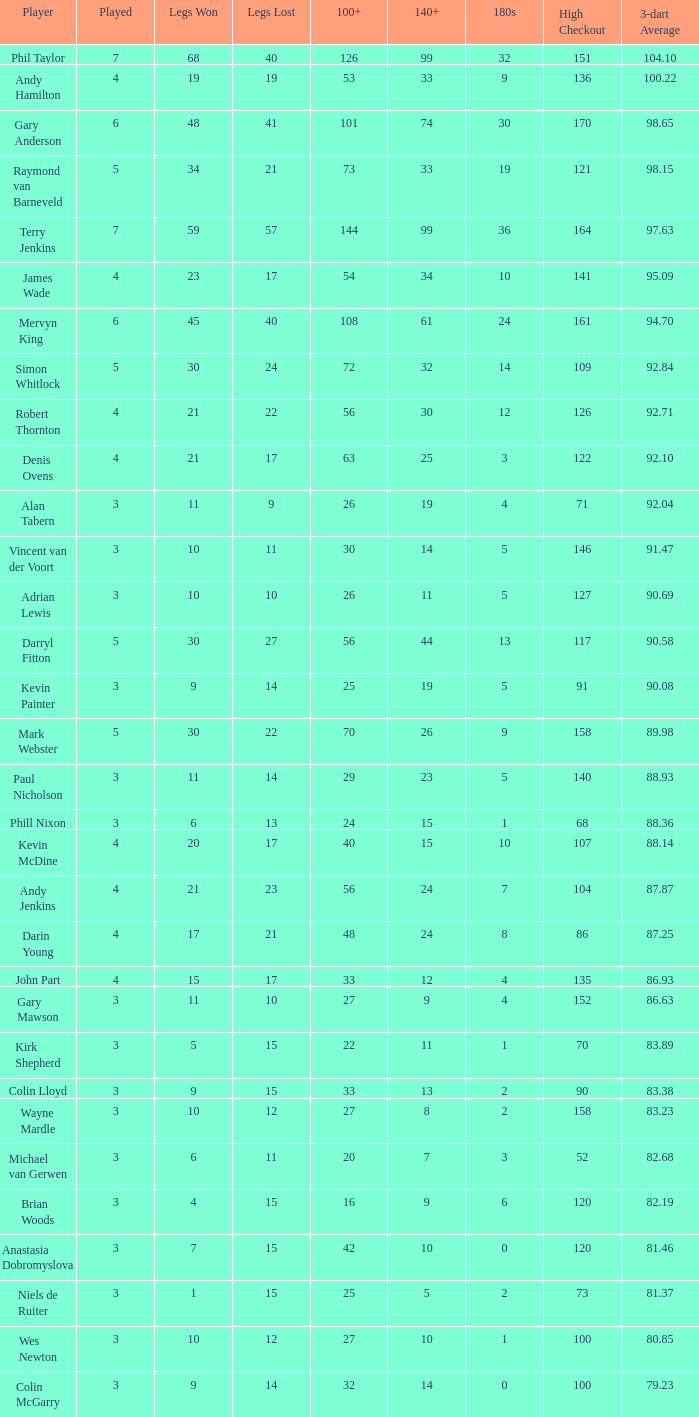When the highest checkout is 140 or more and more than 6 games are played, what is the minimum high checkout value? None. 